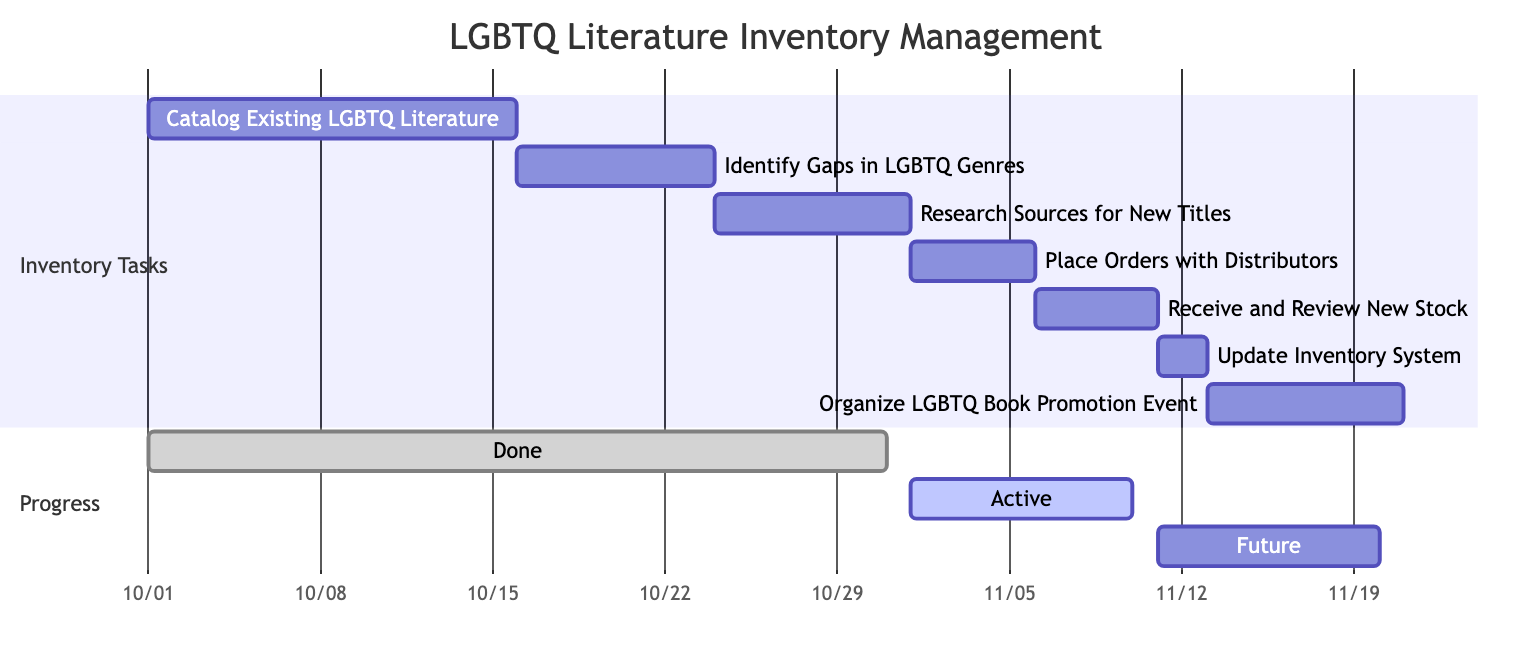What is the duration of the task "Identify Gaps in LGBTQ Genres"? To find the duration of this task, look at its start date, which is October 16, 2023, and its end date, which is October 23, 2023. Counting the days from the start to the end (inclusive), the total is 8 days.
Answer: 8 days What task comes immediately after "Place Orders with Distributors"? The task that follows "Place Orders with Distributors" is "Receive and Review New Stock." This can be determined by examining the dependencies and sequence of tasks in the Gantt chart.
Answer: Receive and Review New Stock How many total tasks are listed in the diagram? To find the total number of tasks, simply count the tasks listed in the "Inventory Tasks" section. There are 7 tasks in total according to the provided data.
Answer: 7 What is the start date of the "Organize LGBTQ Book Promotion Event"? The start date for "Organize LGBTQ Book Promotion Event" is directly provided in the data: November 13, 2023. No calculations are needed as this is explicitly stated.
Answer: 2023-11-13 What task depends on the "Update Inventory System"? The task that depends on "Update Inventory System" is "Organize LGBTQ Book Promotion Event." This dependency is clear from the Gantt chart structure that shows task relationships.
Answer: Organize LGBTQ Book Promotion Event What is the end date of the task "Research Sources for New Titles"? To find the end date of "Research Sources for New Titles," observe its start date, which is October 24, 2023. The duration of this task is 8 days, leading to an end date of October 31, 2023.
Answer: 2023-10-31 Which task has the shortest duration? By analyzing the durations of all tasks, the task "Update Inventory System" has the shortest duration of 2 days, as it spans from November 11 to November 12, 2023.
Answer: 2 days What section contains the "Active" progress? The "Active" progress is found in the "Progress" section of the Gantt chart. This section categorizes tasks based on their current statuses, and "Active" is one of those categories.
Answer: Progress 